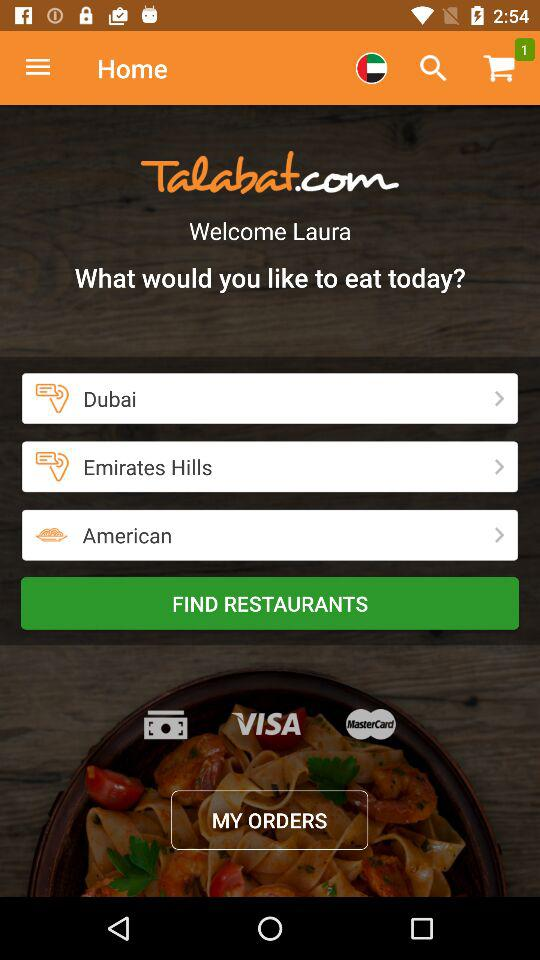What is the name of the city? The name of the city is "Dubai". 